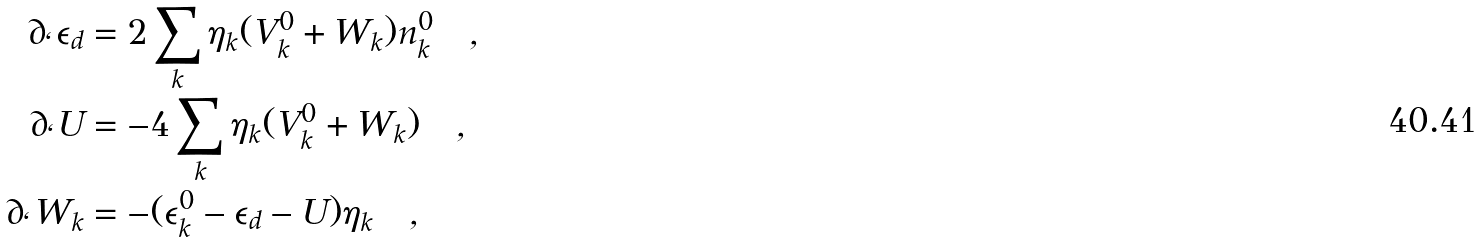<formula> <loc_0><loc_0><loc_500><loc_500>\partial _ { \ell } \epsilon _ { d } & = 2 \sum _ { k } \eta _ { k } ( V _ { k } ^ { 0 } + W _ { k } ) n _ { k } ^ { 0 } \quad , \\ \partial _ { \ell } U & = - 4 \sum _ { k } \eta _ { k } ( V _ { k } ^ { 0 } + W _ { k } ) \quad , \\ \partial _ { \ell } W _ { k } & = - ( \epsilon _ { k } ^ { 0 } - \epsilon _ { d } - U ) \eta _ { k } \quad ,</formula> 